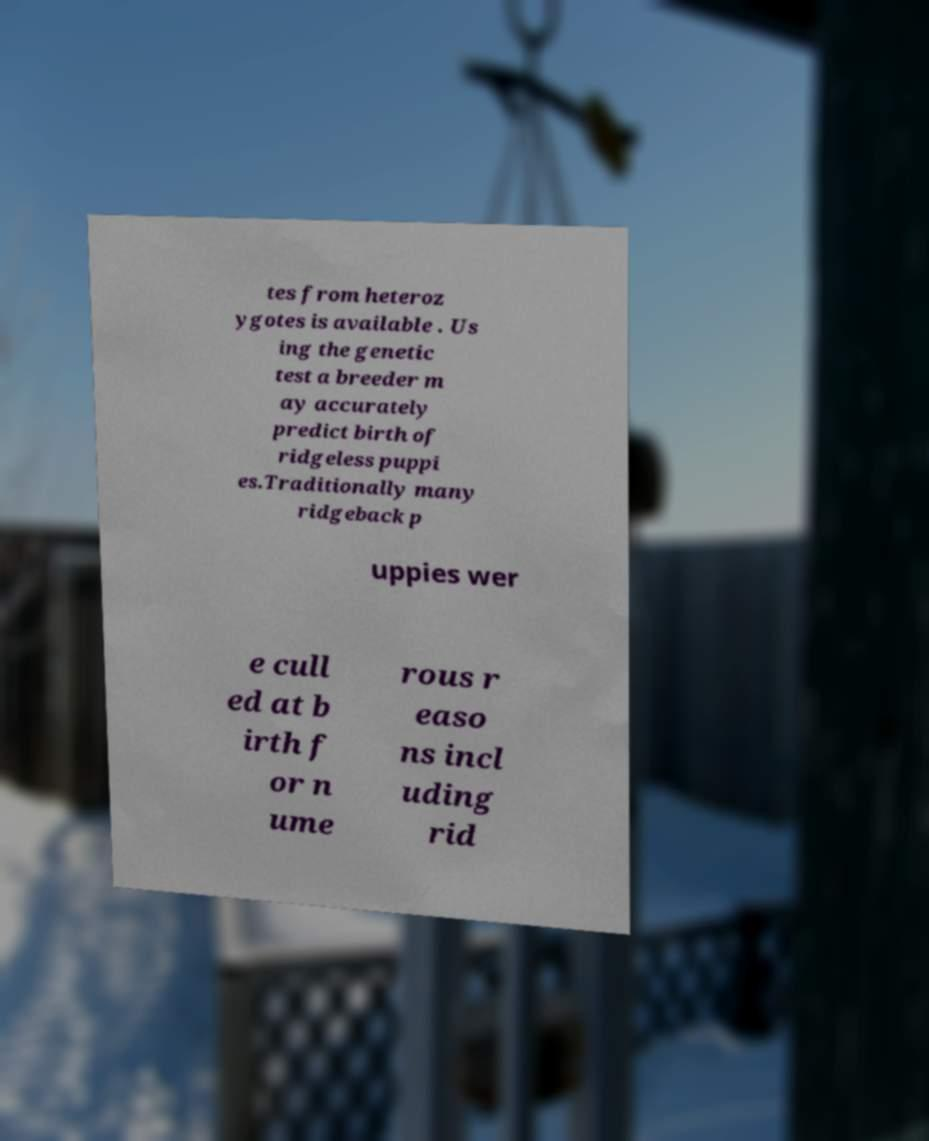Can you accurately transcribe the text from the provided image for me? tes from heteroz ygotes is available . Us ing the genetic test a breeder m ay accurately predict birth of ridgeless puppi es.Traditionally many ridgeback p uppies wer e cull ed at b irth f or n ume rous r easo ns incl uding rid 